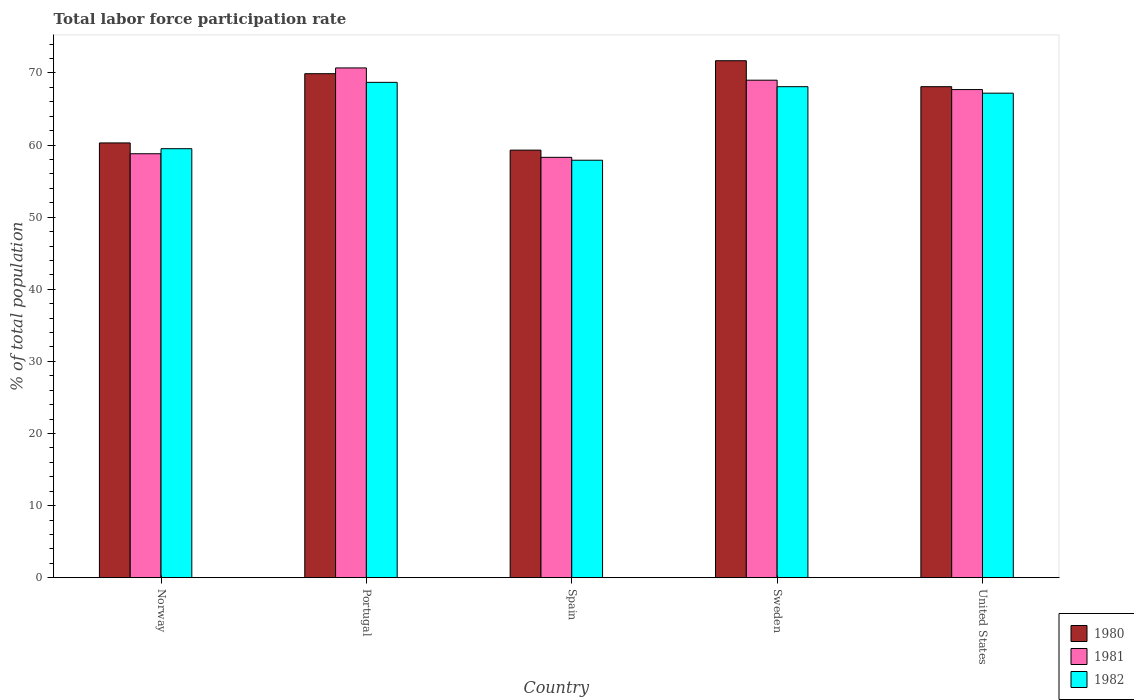How many different coloured bars are there?
Offer a terse response. 3. Are the number of bars per tick equal to the number of legend labels?
Offer a terse response. Yes. How many bars are there on the 4th tick from the right?
Your answer should be compact. 3. What is the label of the 3rd group of bars from the left?
Ensure brevity in your answer.  Spain. What is the total labor force participation rate in 1982 in Spain?
Give a very brief answer. 57.9. Across all countries, what is the maximum total labor force participation rate in 1981?
Provide a short and direct response. 70.7. Across all countries, what is the minimum total labor force participation rate in 1980?
Offer a very short reply. 59.3. In which country was the total labor force participation rate in 1982 minimum?
Provide a succinct answer. Spain. What is the total total labor force participation rate in 1981 in the graph?
Offer a very short reply. 324.5. What is the difference between the total labor force participation rate in 1981 in Norway and that in United States?
Ensure brevity in your answer.  -8.9. What is the difference between the total labor force participation rate in 1982 in Sweden and the total labor force participation rate in 1980 in Norway?
Provide a succinct answer. 7.8. What is the average total labor force participation rate in 1980 per country?
Keep it short and to the point. 65.86. What is the difference between the total labor force participation rate of/in 1982 and total labor force participation rate of/in 1980 in Spain?
Offer a terse response. -1.4. What is the ratio of the total labor force participation rate in 1982 in Spain to that in Sweden?
Provide a succinct answer. 0.85. Is the total labor force participation rate in 1981 in Norway less than that in Portugal?
Your answer should be very brief. Yes. Is the difference between the total labor force participation rate in 1982 in Spain and United States greater than the difference between the total labor force participation rate in 1980 in Spain and United States?
Offer a terse response. No. What is the difference between the highest and the second highest total labor force participation rate in 1981?
Your response must be concise. -1.3. What is the difference between the highest and the lowest total labor force participation rate in 1981?
Give a very brief answer. 12.4. Is the sum of the total labor force participation rate in 1982 in Norway and United States greater than the maximum total labor force participation rate in 1981 across all countries?
Give a very brief answer. Yes. Is it the case that in every country, the sum of the total labor force participation rate in 1980 and total labor force participation rate in 1982 is greater than the total labor force participation rate in 1981?
Provide a succinct answer. Yes. How many bars are there?
Your response must be concise. 15. Are the values on the major ticks of Y-axis written in scientific E-notation?
Offer a very short reply. No. Does the graph contain grids?
Your response must be concise. No. Where does the legend appear in the graph?
Offer a terse response. Bottom right. What is the title of the graph?
Make the answer very short. Total labor force participation rate. Does "1966" appear as one of the legend labels in the graph?
Your answer should be very brief. No. What is the label or title of the X-axis?
Offer a terse response. Country. What is the label or title of the Y-axis?
Your response must be concise. % of total population. What is the % of total population in 1980 in Norway?
Make the answer very short. 60.3. What is the % of total population in 1981 in Norway?
Offer a very short reply. 58.8. What is the % of total population in 1982 in Norway?
Ensure brevity in your answer.  59.5. What is the % of total population of 1980 in Portugal?
Provide a short and direct response. 69.9. What is the % of total population in 1981 in Portugal?
Provide a succinct answer. 70.7. What is the % of total population in 1982 in Portugal?
Keep it short and to the point. 68.7. What is the % of total population of 1980 in Spain?
Keep it short and to the point. 59.3. What is the % of total population of 1981 in Spain?
Give a very brief answer. 58.3. What is the % of total population in 1982 in Spain?
Offer a very short reply. 57.9. What is the % of total population of 1980 in Sweden?
Make the answer very short. 71.7. What is the % of total population in 1982 in Sweden?
Offer a terse response. 68.1. What is the % of total population in 1980 in United States?
Your response must be concise. 68.1. What is the % of total population in 1981 in United States?
Ensure brevity in your answer.  67.7. What is the % of total population in 1982 in United States?
Provide a short and direct response. 67.2. Across all countries, what is the maximum % of total population of 1980?
Your response must be concise. 71.7. Across all countries, what is the maximum % of total population of 1981?
Offer a terse response. 70.7. Across all countries, what is the maximum % of total population of 1982?
Make the answer very short. 68.7. Across all countries, what is the minimum % of total population in 1980?
Your response must be concise. 59.3. Across all countries, what is the minimum % of total population in 1981?
Provide a short and direct response. 58.3. Across all countries, what is the minimum % of total population in 1982?
Your response must be concise. 57.9. What is the total % of total population in 1980 in the graph?
Give a very brief answer. 329.3. What is the total % of total population in 1981 in the graph?
Your answer should be compact. 324.5. What is the total % of total population of 1982 in the graph?
Keep it short and to the point. 321.4. What is the difference between the % of total population of 1980 in Norway and that in Portugal?
Ensure brevity in your answer.  -9.6. What is the difference between the % of total population in 1981 in Norway and that in Portugal?
Make the answer very short. -11.9. What is the difference between the % of total population in 1982 in Norway and that in Portugal?
Offer a terse response. -9.2. What is the difference between the % of total population of 1982 in Norway and that in Spain?
Make the answer very short. 1.6. What is the difference between the % of total population of 1981 in Norway and that in Sweden?
Offer a terse response. -10.2. What is the difference between the % of total population of 1980 in Norway and that in United States?
Provide a short and direct response. -7.8. What is the difference between the % of total population of 1980 in Portugal and that in Spain?
Your answer should be very brief. 10.6. What is the difference between the % of total population of 1982 in Portugal and that in Spain?
Provide a succinct answer. 10.8. What is the difference between the % of total population in 1980 in Portugal and that in Sweden?
Your answer should be very brief. -1.8. What is the difference between the % of total population of 1981 in Portugal and that in Sweden?
Provide a succinct answer. 1.7. What is the difference between the % of total population of 1982 in Portugal and that in Sweden?
Make the answer very short. 0.6. What is the difference between the % of total population of 1981 in Portugal and that in United States?
Your answer should be very brief. 3. What is the difference between the % of total population in 1980 in Spain and that in Sweden?
Offer a terse response. -12.4. What is the difference between the % of total population of 1980 in Spain and that in United States?
Offer a terse response. -8.8. What is the difference between the % of total population of 1981 in Sweden and that in United States?
Offer a very short reply. 1.3. What is the difference between the % of total population of 1982 in Sweden and that in United States?
Provide a succinct answer. 0.9. What is the difference between the % of total population of 1980 in Norway and the % of total population of 1982 in Portugal?
Make the answer very short. -8.4. What is the difference between the % of total population in 1980 in Norway and the % of total population in 1981 in Sweden?
Provide a short and direct response. -8.7. What is the difference between the % of total population in 1980 in Norway and the % of total population in 1982 in Sweden?
Provide a succinct answer. -7.8. What is the difference between the % of total population of 1981 in Norway and the % of total population of 1982 in Sweden?
Offer a very short reply. -9.3. What is the difference between the % of total population in 1980 in Norway and the % of total population in 1981 in United States?
Keep it short and to the point. -7.4. What is the difference between the % of total population in 1980 in Portugal and the % of total population in 1981 in Spain?
Your answer should be compact. 11.6. What is the difference between the % of total population of 1981 in Portugal and the % of total population of 1982 in Spain?
Make the answer very short. 12.8. What is the difference between the % of total population of 1980 in Portugal and the % of total population of 1982 in Sweden?
Your response must be concise. 1.8. What is the difference between the % of total population of 1980 in Portugal and the % of total population of 1982 in United States?
Offer a very short reply. 2.7. What is the difference between the % of total population of 1981 in Portugal and the % of total population of 1982 in United States?
Offer a very short reply. 3.5. What is the difference between the % of total population in 1980 in Spain and the % of total population in 1982 in Sweden?
Provide a succinct answer. -8.8. What is the difference between the % of total population in 1980 in Spain and the % of total population in 1981 in United States?
Your response must be concise. -8.4. What is the difference between the % of total population in 1980 in Spain and the % of total population in 1982 in United States?
Your answer should be very brief. -7.9. What is the difference between the % of total population of 1981 in Spain and the % of total population of 1982 in United States?
Provide a succinct answer. -8.9. What is the difference between the % of total population in 1980 in Sweden and the % of total population in 1982 in United States?
Offer a terse response. 4.5. What is the difference between the % of total population of 1981 in Sweden and the % of total population of 1982 in United States?
Provide a short and direct response. 1.8. What is the average % of total population in 1980 per country?
Keep it short and to the point. 65.86. What is the average % of total population of 1981 per country?
Offer a terse response. 64.9. What is the average % of total population of 1982 per country?
Your answer should be very brief. 64.28. What is the difference between the % of total population in 1980 and % of total population in 1981 in Norway?
Ensure brevity in your answer.  1.5. What is the difference between the % of total population in 1980 and % of total population in 1982 in Norway?
Your answer should be compact. 0.8. What is the difference between the % of total population of 1981 and % of total population of 1982 in Norway?
Offer a terse response. -0.7. What is the difference between the % of total population of 1980 and % of total population of 1981 in Spain?
Make the answer very short. 1. What is the difference between the % of total population in 1980 and % of total population in 1982 in Sweden?
Provide a succinct answer. 3.6. What is the difference between the % of total population in 1980 and % of total population in 1981 in United States?
Give a very brief answer. 0.4. What is the ratio of the % of total population in 1980 in Norway to that in Portugal?
Your answer should be very brief. 0.86. What is the ratio of the % of total population of 1981 in Norway to that in Portugal?
Give a very brief answer. 0.83. What is the ratio of the % of total population of 1982 in Norway to that in Portugal?
Make the answer very short. 0.87. What is the ratio of the % of total population in 1980 in Norway to that in Spain?
Keep it short and to the point. 1.02. What is the ratio of the % of total population in 1981 in Norway to that in Spain?
Make the answer very short. 1.01. What is the ratio of the % of total population in 1982 in Norway to that in Spain?
Give a very brief answer. 1.03. What is the ratio of the % of total population in 1980 in Norway to that in Sweden?
Your response must be concise. 0.84. What is the ratio of the % of total population in 1981 in Norway to that in Sweden?
Provide a short and direct response. 0.85. What is the ratio of the % of total population of 1982 in Norway to that in Sweden?
Provide a succinct answer. 0.87. What is the ratio of the % of total population in 1980 in Norway to that in United States?
Provide a succinct answer. 0.89. What is the ratio of the % of total population of 1981 in Norway to that in United States?
Give a very brief answer. 0.87. What is the ratio of the % of total population of 1982 in Norway to that in United States?
Offer a very short reply. 0.89. What is the ratio of the % of total population in 1980 in Portugal to that in Spain?
Your answer should be very brief. 1.18. What is the ratio of the % of total population of 1981 in Portugal to that in Spain?
Offer a very short reply. 1.21. What is the ratio of the % of total population in 1982 in Portugal to that in Spain?
Offer a terse response. 1.19. What is the ratio of the % of total population of 1980 in Portugal to that in Sweden?
Offer a terse response. 0.97. What is the ratio of the % of total population in 1981 in Portugal to that in Sweden?
Your answer should be very brief. 1.02. What is the ratio of the % of total population of 1982 in Portugal to that in Sweden?
Your answer should be very brief. 1.01. What is the ratio of the % of total population in 1980 in Portugal to that in United States?
Your answer should be compact. 1.03. What is the ratio of the % of total population of 1981 in Portugal to that in United States?
Make the answer very short. 1.04. What is the ratio of the % of total population in 1982 in Portugal to that in United States?
Provide a short and direct response. 1.02. What is the ratio of the % of total population in 1980 in Spain to that in Sweden?
Provide a succinct answer. 0.83. What is the ratio of the % of total population in 1981 in Spain to that in Sweden?
Ensure brevity in your answer.  0.84. What is the ratio of the % of total population of 1982 in Spain to that in Sweden?
Keep it short and to the point. 0.85. What is the ratio of the % of total population in 1980 in Spain to that in United States?
Your response must be concise. 0.87. What is the ratio of the % of total population in 1981 in Spain to that in United States?
Keep it short and to the point. 0.86. What is the ratio of the % of total population of 1982 in Spain to that in United States?
Provide a short and direct response. 0.86. What is the ratio of the % of total population in 1980 in Sweden to that in United States?
Your answer should be very brief. 1.05. What is the ratio of the % of total population of 1981 in Sweden to that in United States?
Keep it short and to the point. 1.02. What is the ratio of the % of total population of 1982 in Sweden to that in United States?
Provide a succinct answer. 1.01. What is the difference between the highest and the second highest % of total population in 1980?
Your answer should be compact. 1.8. What is the difference between the highest and the second highest % of total population of 1981?
Provide a succinct answer. 1.7. What is the difference between the highest and the lowest % of total population of 1981?
Your response must be concise. 12.4. 